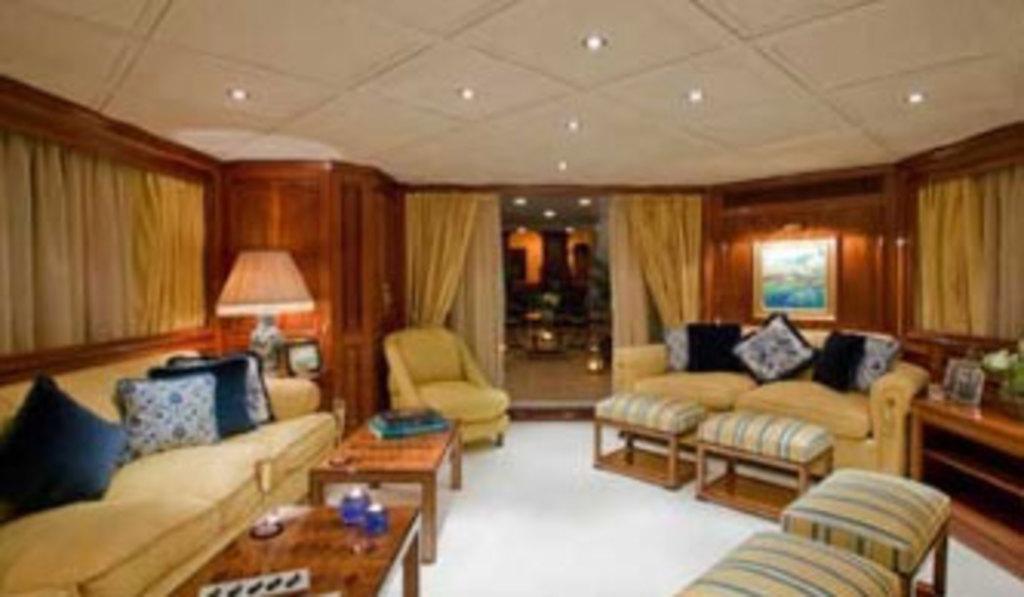Please provide a concise description of this image. In this image I can see two sofas and cushions on it. I can also see tables, curtains on windows, door. 